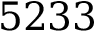Convert formula to latex. <formula><loc_0><loc_0><loc_500><loc_500>5 2 3 3</formula> 